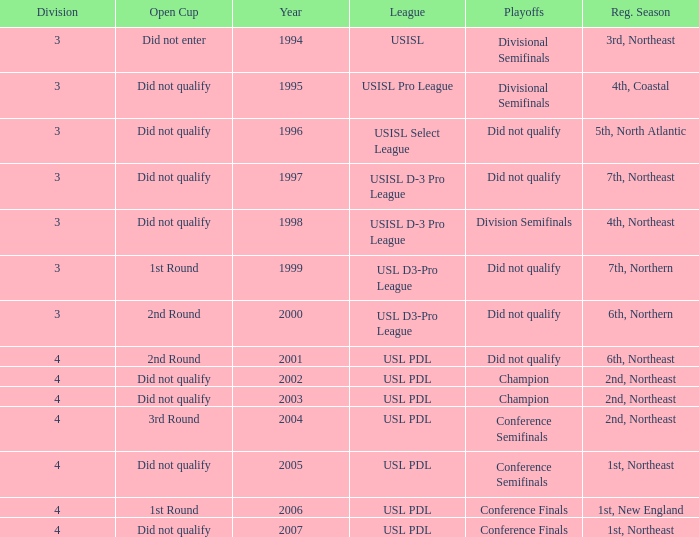Mame the reg season for 2001 6th, Northeast. 